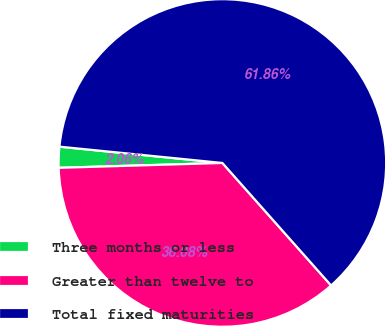<chart> <loc_0><loc_0><loc_500><loc_500><pie_chart><fcel>Three months or less<fcel>Greater than twelve to<fcel>Total fixed maturities<nl><fcel>2.06%<fcel>36.08%<fcel>61.86%<nl></chart> 